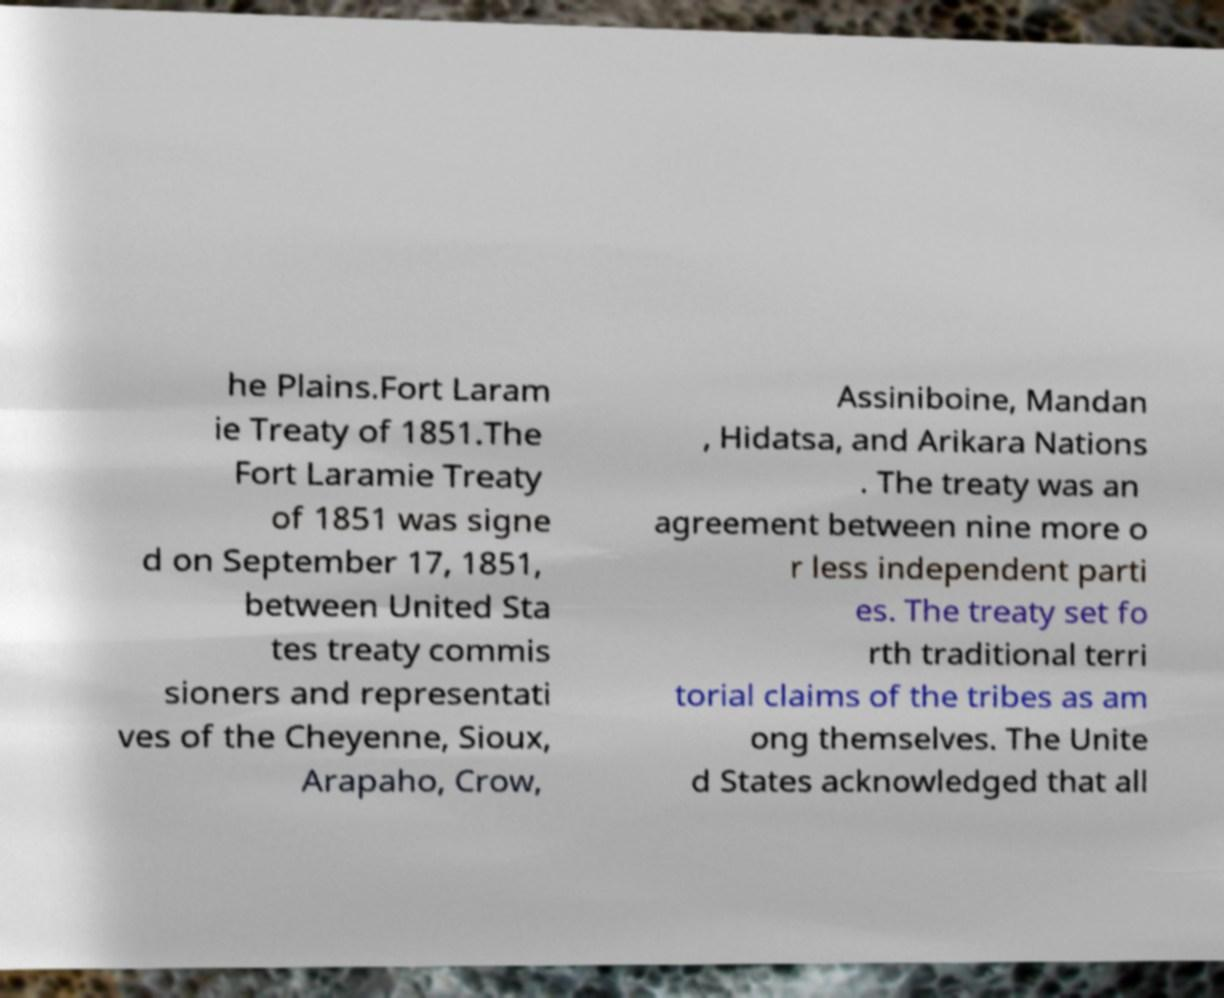What messages or text are displayed in this image? I need them in a readable, typed format. he Plains.Fort Laram ie Treaty of 1851.The Fort Laramie Treaty of 1851 was signe d on September 17, 1851, between United Sta tes treaty commis sioners and representati ves of the Cheyenne, Sioux, Arapaho, Crow, Assiniboine, Mandan , Hidatsa, and Arikara Nations . The treaty was an agreement between nine more o r less independent parti es. The treaty set fo rth traditional terri torial claims of the tribes as am ong themselves. The Unite d States acknowledged that all 